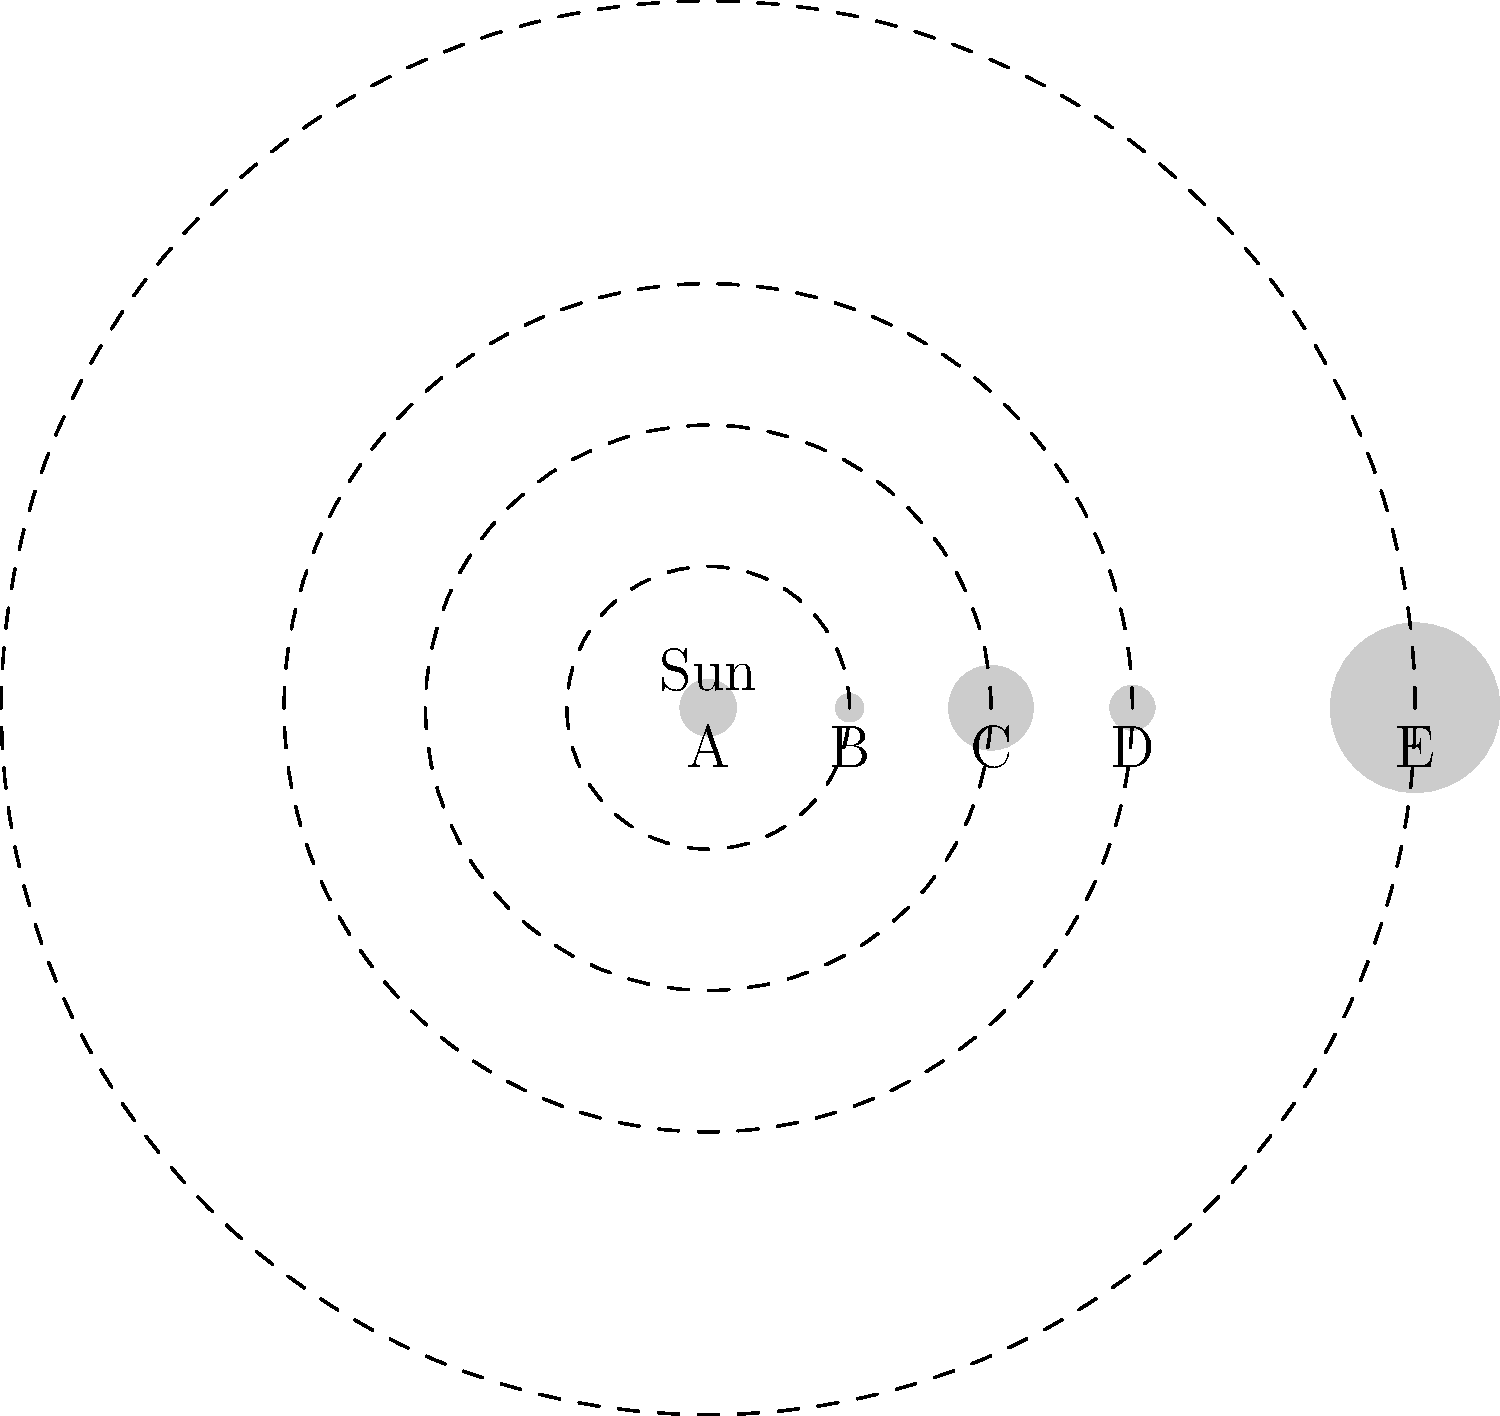In the diagram above, which represents a simplified view of our Solar System, planets are labeled A through E. Based on your understanding of the relative sizes and positions of planets, which label most likely represents Jupiter? To determine which label most likely represents Jupiter, we need to consider two key factors: size and position in the Solar System.

1. Size: Jupiter is the largest planet in our Solar System. In the diagram, we can see that planet E is significantly larger than the others, which aligns with Jupiter's characteristics.

2. Position: Jupiter is the fifth planet from the Sun, after Mercury, Venus, Earth, and Mars. In our simplified diagram, we can count five planets, with E being the fifth and outermost one.

3. Relative sizes: The inner planets (Mercury, Venus, Earth, and Mars) are much smaller than the gas giants, with Jupiter being the largest. This is accurately represented in the diagram, where the first four planets (A, B, C, and D) are smaller compared to E.

4. Order of planets: The diagram shows a correct representation of increasing orbital distances from the Sun, which matches the actual arrangement of planets in our Solar System.

Given these considerations, the planet labeled E best fits the characteristics of Jupiter in terms of both size and position.
Answer: E 